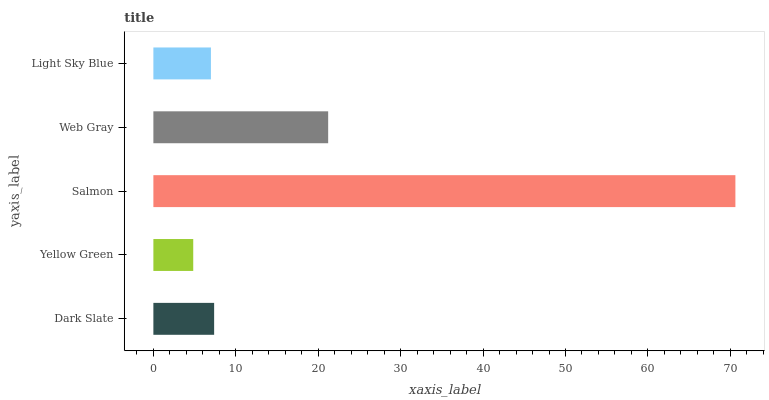Is Yellow Green the minimum?
Answer yes or no. Yes. Is Salmon the maximum?
Answer yes or no. Yes. Is Salmon the minimum?
Answer yes or no. No. Is Yellow Green the maximum?
Answer yes or no. No. Is Salmon greater than Yellow Green?
Answer yes or no. Yes. Is Yellow Green less than Salmon?
Answer yes or no. Yes. Is Yellow Green greater than Salmon?
Answer yes or no. No. Is Salmon less than Yellow Green?
Answer yes or no. No. Is Dark Slate the high median?
Answer yes or no. Yes. Is Dark Slate the low median?
Answer yes or no. Yes. Is Salmon the high median?
Answer yes or no. No. Is Yellow Green the low median?
Answer yes or no. No. 